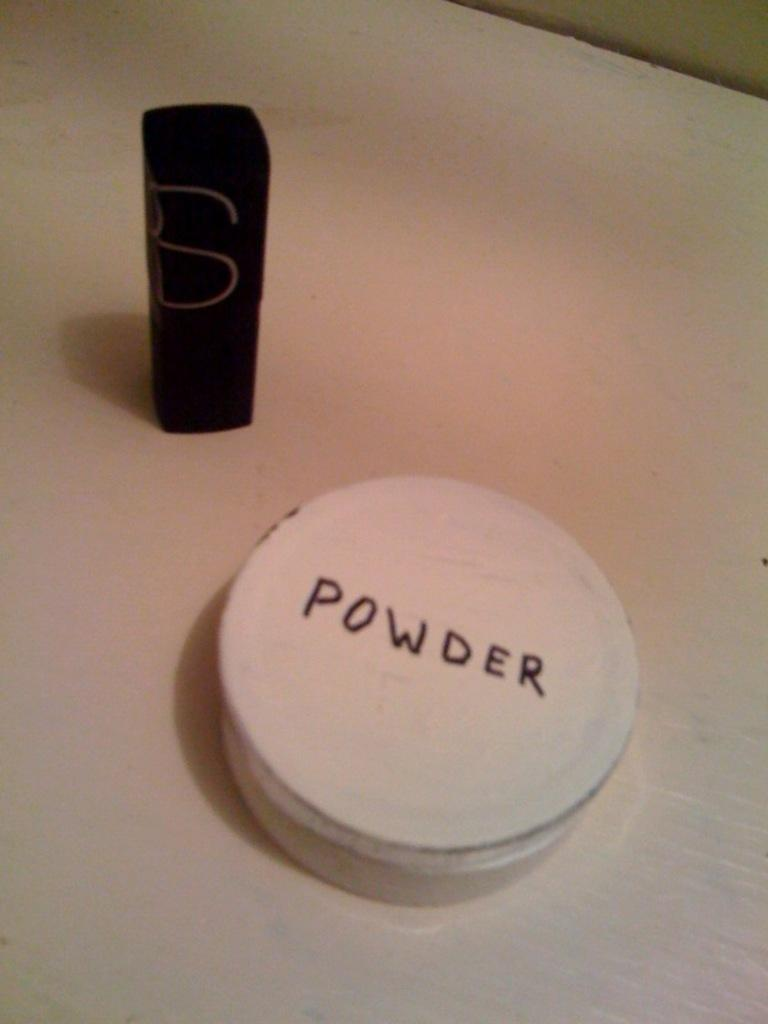Provide a one-sentence caption for the provided image. A small jar of powder is labeled with hand printed capital letters. 